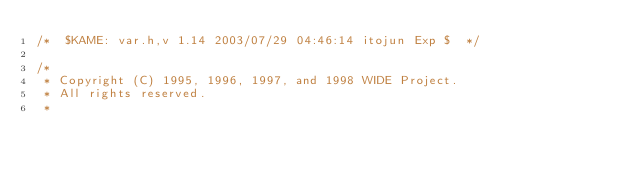<code> <loc_0><loc_0><loc_500><loc_500><_C_>/*	$KAME: var.h,v 1.14 2003/07/29 04:46:14 itojun Exp $	*/

/*
 * Copyright (C) 1995, 1996, 1997, and 1998 WIDE Project.
 * All rights reserved.
 * </code> 